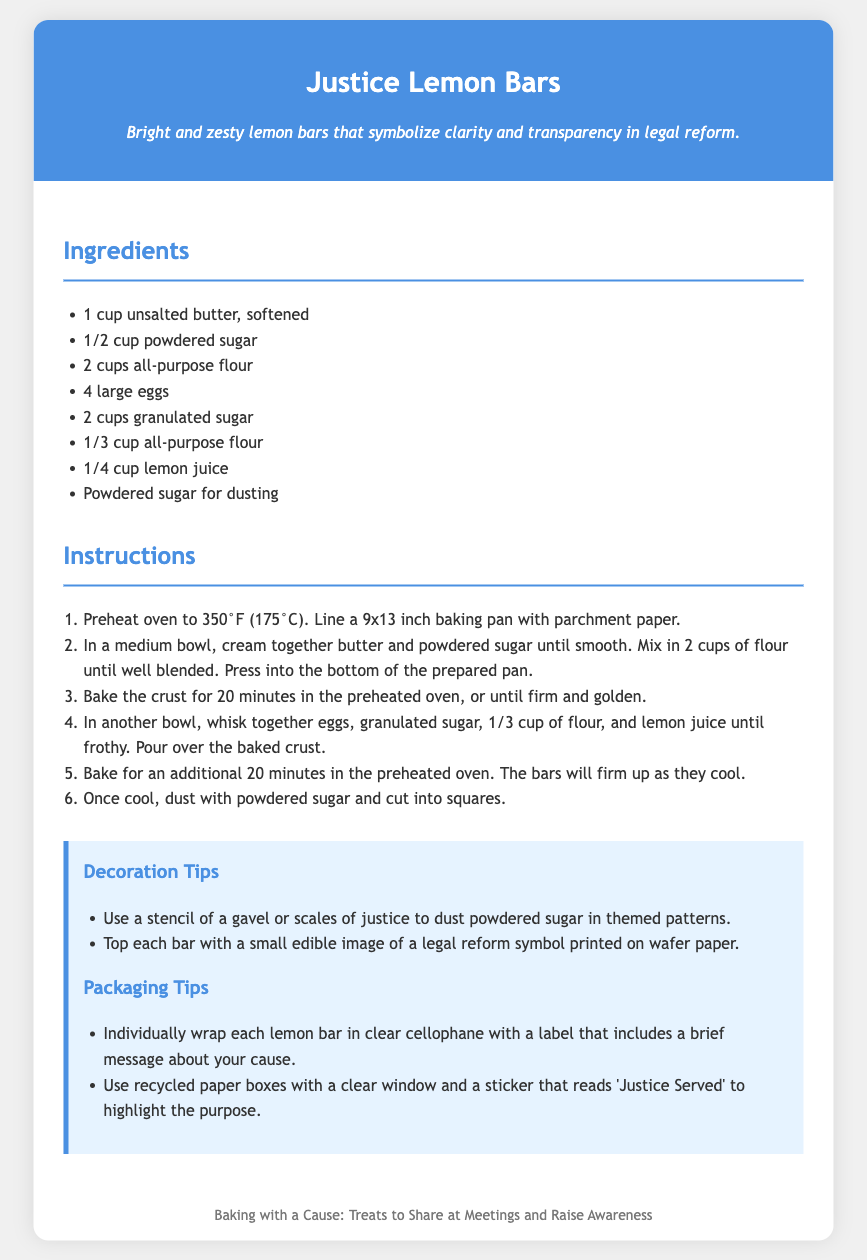what is the title of the recipe? The title of the recipe is presented prominently at the top of the document.
Answer: Justice Lemon Bars how many large eggs are needed? The ingredients list specifies the number of each ingredient, which includes eggs.
Answer: 4 large eggs what is the baking temperature? The instructions section indicates the temperature for preheating the oven.
Answer: 350°F (175°C) what decoration tip involves edible images? The decoration tips include a specific method for using edible images, which pertains to legal reform symbols.
Answer: Top each bar with a small edible image of a legal reform symbol printed on wafer paper what is the message suggested for the labels? The packaging tips mention a brief message to include on the labels for the wrapped lemon bars.
Answer: a brief message about your cause how long should the crust be baked? The instructions provide a specific duration for baking the crust.
Answer: 20 minutes what is included in the recipe description? The recipe description gives context about the meaning behind the treats.
Answer: Clarity and transparency in legal reform how should the lemon bars be packaged? The document includes a suggestion on how to package the lemon bars for sharing.
Answer: Individually wrap each lemon bar in clear cellophane with a label 